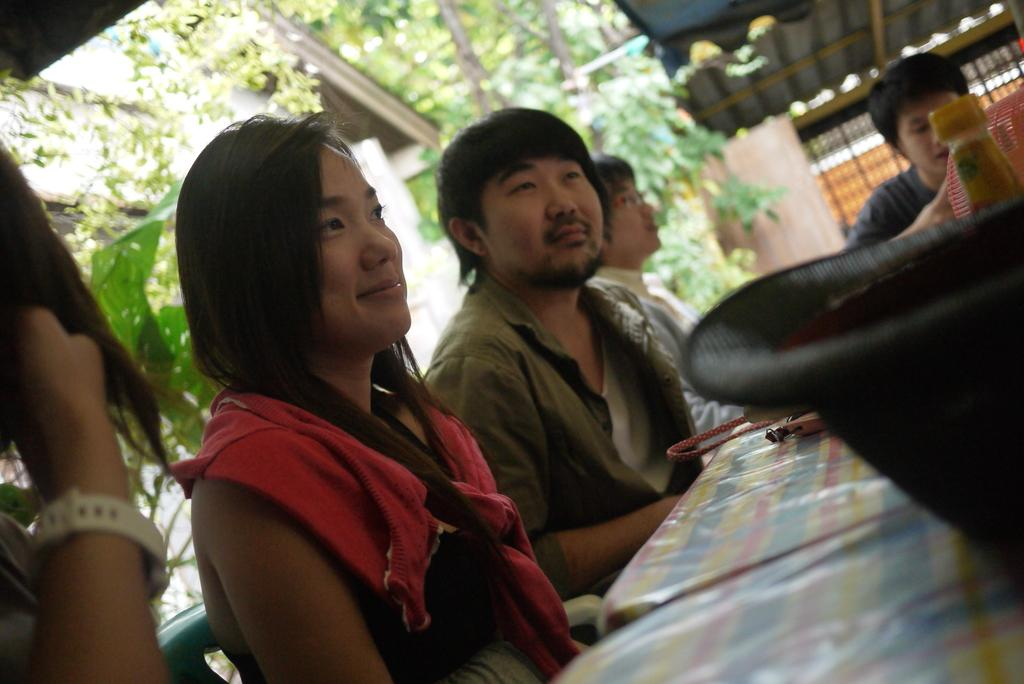What are the people in the image doing? The people in the image are seated on chairs. What is in front of the chairs? There is a table in front of the chairs. What can be seen in the background of the image? There are trees and a rooftop visible in the background of the image. What type of paper is the beginner using to practice with the rifle in the image? There is no paper, beginner, or rifle present in the image. 